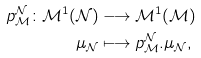Convert formula to latex. <formula><loc_0><loc_0><loc_500><loc_500>p _ { \mathcal { M } } ^ { \mathcal { N } } \colon \mathcal { M } ^ { 1 } ( \mathcal { N ) } & \longrightarrow \mathcal { M } ^ { 1 } ( \mathcal { M ) } \\ \mu _ { \mathcal { N } } & \longmapsto p _ { \mathcal { M } } ^ { \mathcal { N } } . \mu _ { \mathcal { N } } ,</formula> 